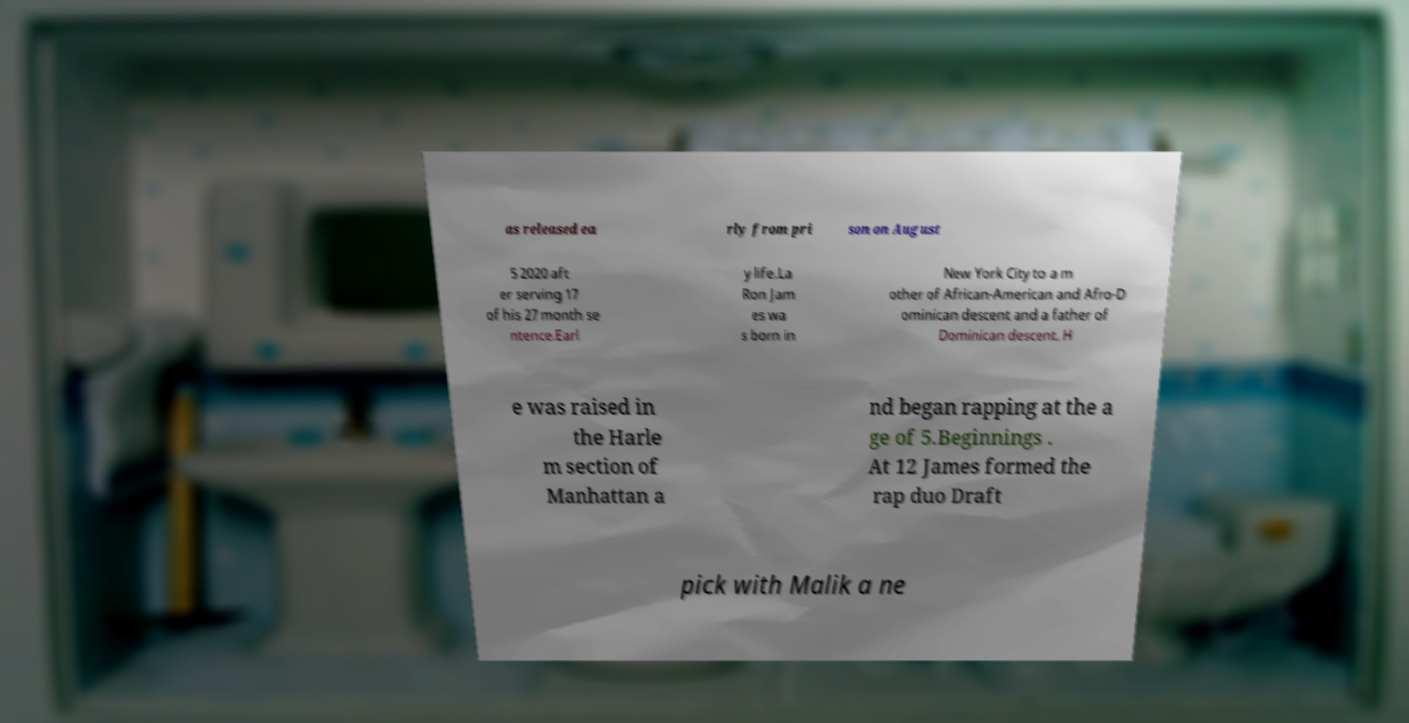There's text embedded in this image that I need extracted. Can you transcribe it verbatim? as released ea rly from pri son on August 5 2020 aft er serving 17 of his 27 month se ntence.Earl y life.La Ron Jam es wa s born in New York City to a m other of African-American and Afro-D ominican descent and a father of Dominican descent. H e was raised in the Harle m section of Manhattan a nd began rapping at the a ge of 5.Beginnings . At 12 James formed the rap duo Draft pick with Malik a ne 